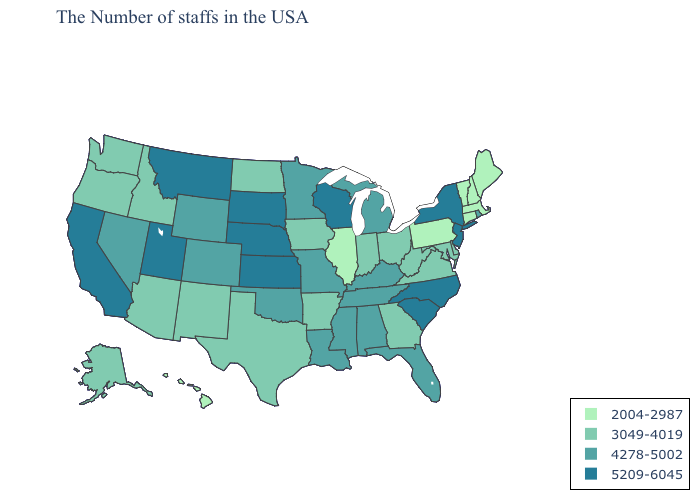Does the map have missing data?
Be succinct. No. Which states have the lowest value in the West?
Short answer required. Hawaii. Does Kansas have the same value as Wisconsin?
Be succinct. Yes. Does Nebraska have the highest value in the MidWest?
Give a very brief answer. Yes. What is the value of Montana?
Concise answer only. 5209-6045. Among the states that border Pennsylvania , which have the highest value?
Write a very short answer. New York, New Jersey. Name the states that have a value in the range 3049-4019?
Write a very short answer. Delaware, Maryland, Virginia, West Virginia, Ohio, Georgia, Indiana, Arkansas, Iowa, Texas, North Dakota, New Mexico, Arizona, Idaho, Washington, Oregon, Alaska. Does South Carolina have the highest value in the USA?
Answer briefly. Yes. Does Texas have a lower value than Massachusetts?
Answer briefly. No. What is the value of Texas?
Concise answer only. 3049-4019. Does the map have missing data?
Give a very brief answer. No. Which states have the highest value in the USA?
Short answer required. New York, New Jersey, North Carolina, South Carolina, Wisconsin, Kansas, Nebraska, South Dakota, Utah, Montana, California. Among the states that border Mississippi , does Arkansas have the highest value?
Short answer required. No. Name the states that have a value in the range 3049-4019?
Quick response, please. Delaware, Maryland, Virginia, West Virginia, Ohio, Georgia, Indiana, Arkansas, Iowa, Texas, North Dakota, New Mexico, Arizona, Idaho, Washington, Oregon, Alaska. What is the value of Minnesota?
Concise answer only. 4278-5002. 